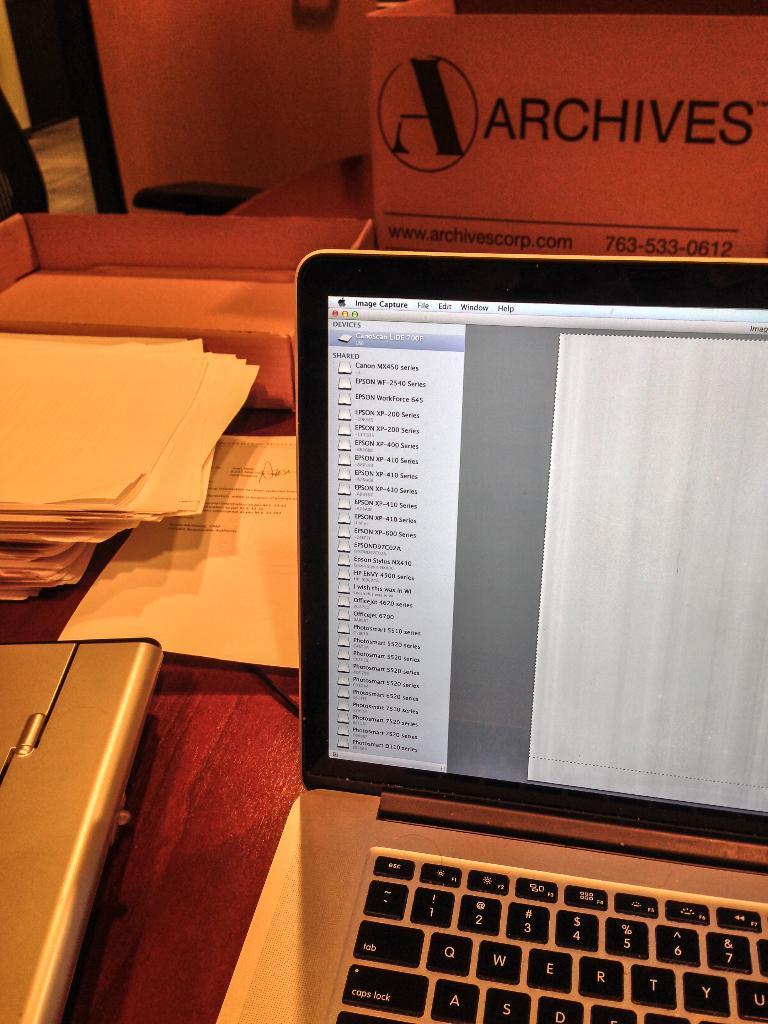Are they at the archives?
Your answer should be very brief. Yes. What is the phone number on the archives box?
Your answer should be compact. 763-533-0612. 